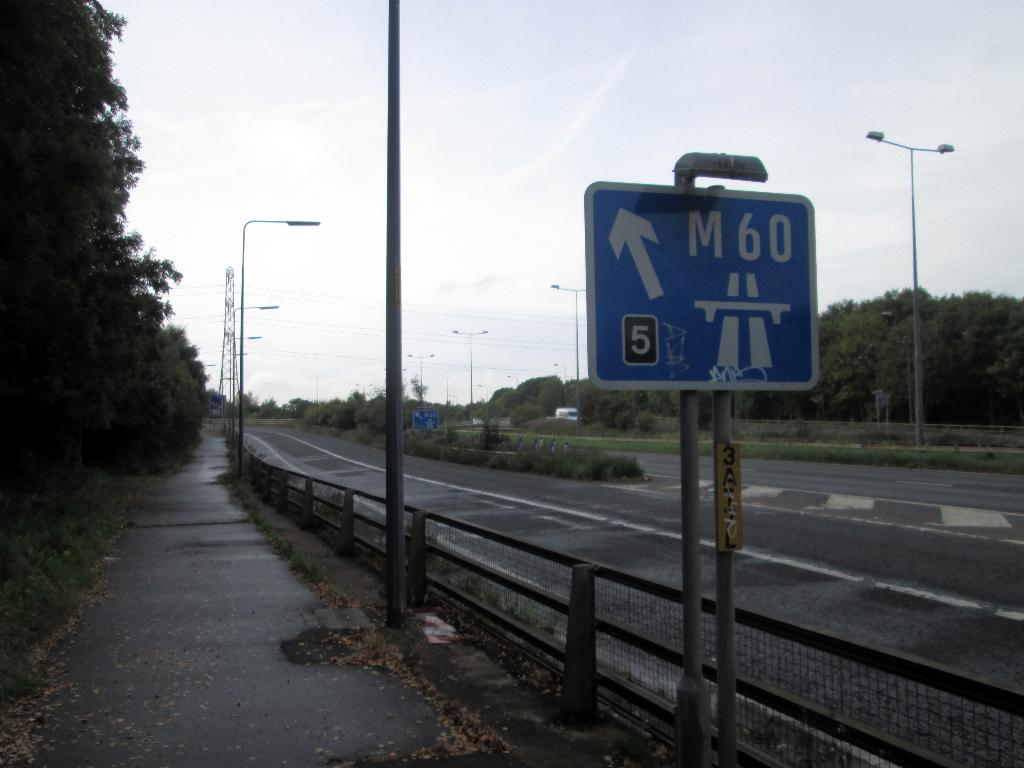<image>
Present a compact description of the photo's key features. A blue sign on the road with an arrow and a 5 that has a M60 on it too. 